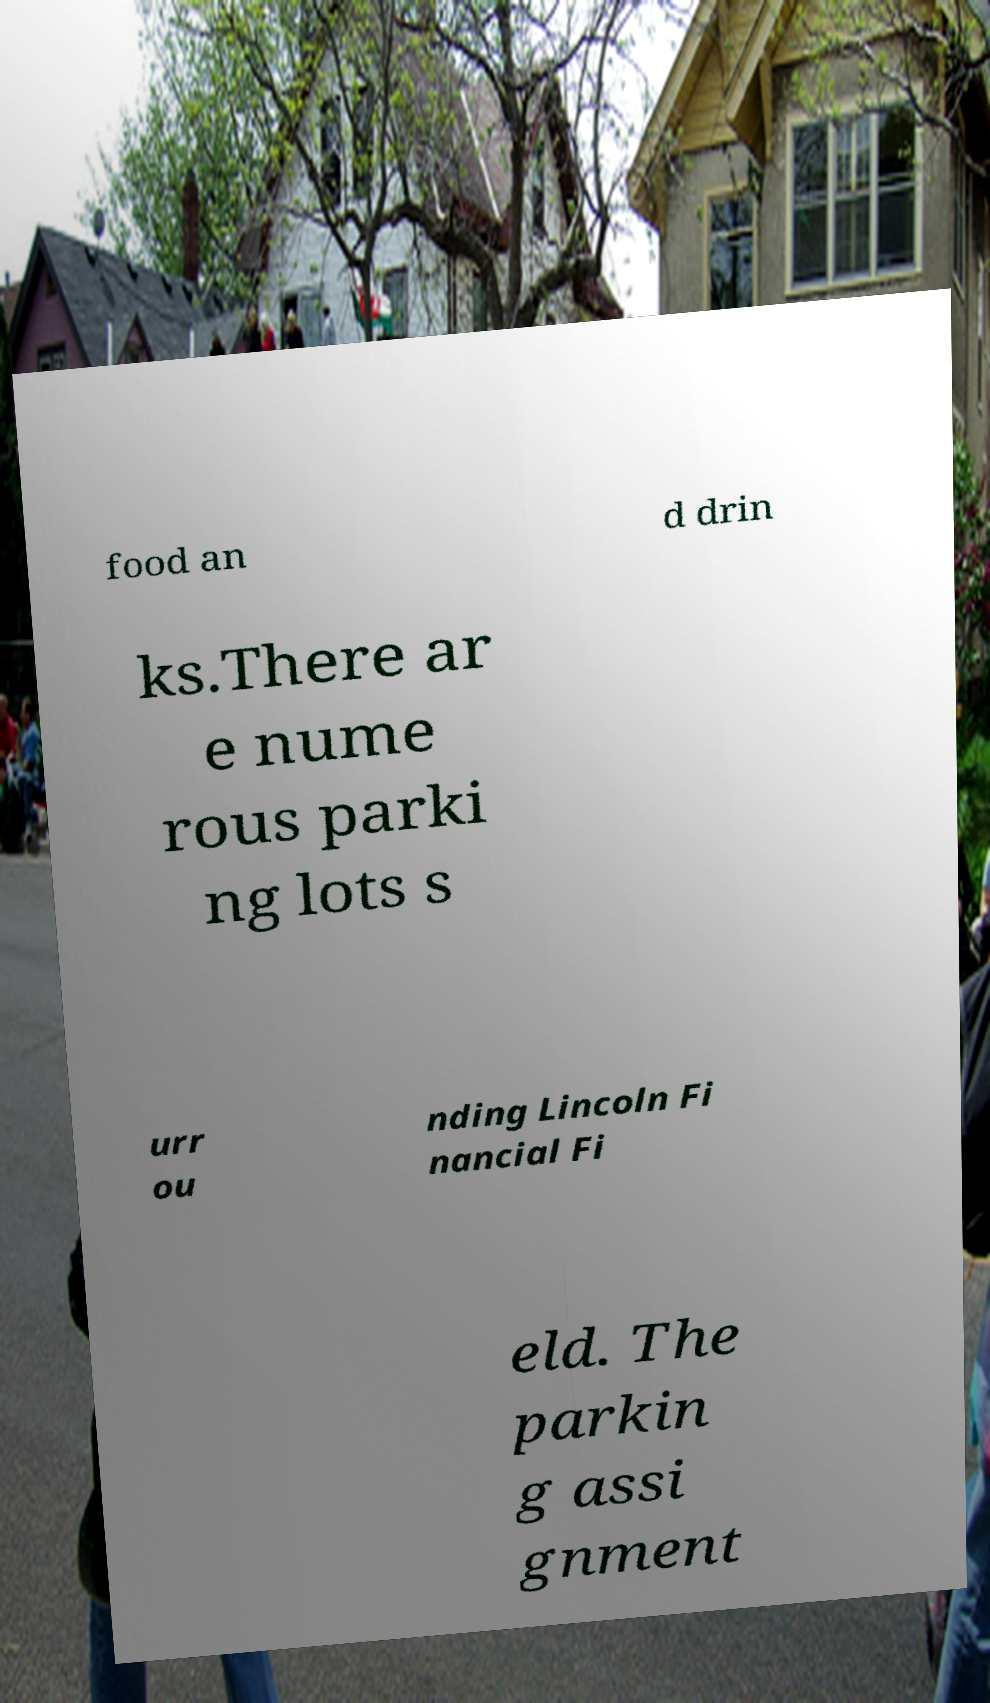Could you extract and type out the text from this image? food an d drin ks.There ar e nume rous parki ng lots s urr ou nding Lincoln Fi nancial Fi eld. The parkin g assi gnment 